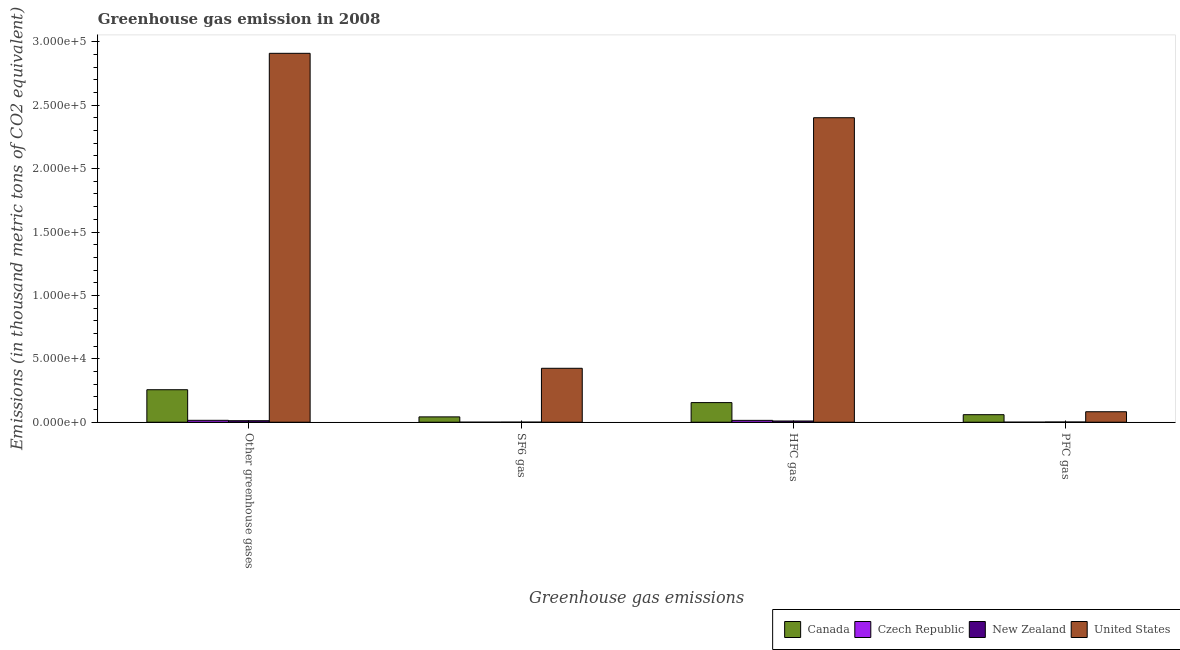How many different coloured bars are there?
Ensure brevity in your answer.  4. Are the number of bars per tick equal to the number of legend labels?
Offer a terse response. Yes. How many bars are there on the 3rd tick from the left?
Make the answer very short. 4. How many bars are there on the 2nd tick from the right?
Offer a very short reply. 4. What is the label of the 2nd group of bars from the left?
Your response must be concise. SF6 gas. Across all countries, what is the maximum emission of pfc gas?
Provide a succinct answer. 8264. Across all countries, what is the minimum emission of greenhouse gases?
Offer a very short reply. 1199.3. In which country was the emission of hfc gas maximum?
Give a very brief answer. United States. In which country was the emission of sf6 gas minimum?
Provide a short and direct response. Czech Republic. What is the total emission of pfc gas in the graph?
Make the answer very short. 1.44e+04. What is the difference between the emission of sf6 gas in Canada and that in New Zealand?
Offer a terse response. 4147.3. What is the difference between the emission of greenhouse gases in Czech Republic and the emission of pfc gas in United States?
Offer a terse response. -6767. What is the average emission of sf6 gas per country?
Offer a terse response. 1.17e+04. What is the difference between the emission of pfc gas and emission of greenhouse gases in Canada?
Keep it short and to the point. -1.97e+04. What is the ratio of the emission of pfc gas in Canada to that in New Zealand?
Give a very brief answer. 35.72. What is the difference between the highest and the second highest emission of sf6 gas?
Your answer should be very brief. 3.83e+04. What is the difference between the highest and the lowest emission of greenhouse gases?
Provide a short and direct response. 2.90e+05. Is the sum of the emission of pfc gas in United States and Czech Republic greater than the maximum emission of hfc gas across all countries?
Give a very brief answer. No. What does the 2nd bar from the left in PFC gas represents?
Offer a very short reply. Czech Republic. Is it the case that in every country, the sum of the emission of greenhouse gases and emission of sf6 gas is greater than the emission of hfc gas?
Ensure brevity in your answer.  Yes. How many bars are there?
Your answer should be very brief. 16. Are all the bars in the graph horizontal?
Give a very brief answer. No. How many countries are there in the graph?
Give a very brief answer. 4. What is the difference between two consecutive major ticks on the Y-axis?
Ensure brevity in your answer.  5.00e+04. Are the values on the major ticks of Y-axis written in scientific E-notation?
Offer a very short reply. Yes. Does the graph contain any zero values?
Offer a very short reply. No. How many legend labels are there?
Keep it short and to the point. 4. How are the legend labels stacked?
Your answer should be compact. Horizontal. What is the title of the graph?
Offer a terse response. Greenhouse gas emission in 2008. What is the label or title of the X-axis?
Provide a short and direct response. Greenhouse gas emissions. What is the label or title of the Y-axis?
Provide a succinct answer. Emissions (in thousand metric tons of CO2 equivalent). What is the Emissions (in thousand metric tons of CO2 equivalent) in Canada in Other greenhouse gases?
Your answer should be very brief. 2.56e+04. What is the Emissions (in thousand metric tons of CO2 equivalent) of Czech Republic in Other greenhouse gases?
Your answer should be compact. 1497. What is the Emissions (in thousand metric tons of CO2 equivalent) of New Zealand in Other greenhouse gases?
Your answer should be very brief. 1199.3. What is the Emissions (in thousand metric tons of CO2 equivalent) of United States in Other greenhouse gases?
Keep it short and to the point. 2.91e+05. What is the Emissions (in thousand metric tons of CO2 equivalent) of Canada in SF6 gas?
Give a very brief answer. 4208.8. What is the Emissions (in thousand metric tons of CO2 equivalent) of Czech Republic in SF6 gas?
Your answer should be very brief. 4.7. What is the Emissions (in thousand metric tons of CO2 equivalent) of New Zealand in SF6 gas?
Offer a very short reply. 61.5. What is the Emissions (in thousand metric tons of CO2 equivalent) in United States in SF6 gas?
Provide a succinct answer. 4.25e+04. What is the Emissions (in thousand metric tons of CO2 equivalent) in Canada in HFC gas?
Offer a very short reply. 1.55e+04. What is the Emissions (in thousand metric tons of CO2 equivalent) in Czech Republic in HFC gas?
Keep it short and to the point. 1459. What is the Emissions (in thousand metric tons of CO2 equivalent) of New Zealand in HFC gas?
Give a very brief answer. 971.4. What is the Emissions (in thousand metric tons of CO2 equivalent) in United States in HFC gas?
Your answer should be very brief. 2.40e+05. What is the Emissions (in thousand metric tons of CO2 equivalent) of Canada in PFC gas?
Your answer should be very brief. 5943.7. What is the Emissions (in thousand metric tons of CO2 equivalent) of Czech Republic in PFC gas?
Your answer should be compact. 33.3. What is the Emissions (in thousand metric tons of CO2 equivalent) of New Zealand in PFC gas?
Provide a short and direct response. 166.4. What is the Emissions (in thousand metric tons of CO2 equivalent) in United States in PFC gas?
Keep it short and to the point. 8264. Across all Greenhouse gas emissions, what is the maximum Emissions (in thousand metric tons of CO2 equivalent) in Canada?
Your response must be concise. 2.56e+04. Across all Greenhouse gas emissions, what is the maximum Emissions (in thousand metric tons of CO2 equivalent) of Czech Republic?
Offer a terse response. 1497. Across all Greenhouse gas emissions, what is the maximum Emissions (in thousand metric tons of CO2 equivalent) of New Zealand?
Keep it short and to the point. 1199.3. Across all Greenhouse gas emissions, what is the maximum Emissions (in thousand metric tons of CO2 equivalent) of United States?
Your answer should be very brief. 2.91e+05. Across all Greenhouse gas emissions, what is the minimum Emissions (in thousand metric tons of CO2 equivalent) in Canada?
Your answer should be compact. 4208.8. Across all Greenhouse gas emissions, what is the minimum Emissions (in thousand metric tons of CO2 equivalent) of New Zealand?
Keep it short and to the point. 61.5. Across all Greenhouse gas emissions, what is the minimum Emissions (in thousand metric tons of CO2 equivalent) in United States?
Ensure brevity in your answer.  8264. What is the total Emissions (in thousand metric tons of CO2 equivalent) of Canada in the graph?
Keep it short and to the point. 5.13e+04. What is the total Emissions (in thousand metric tons of CO2 equivalent) of Czech Republic in the graph?
Provide a succinct answer. 2994. What is the total Emissions (in thousand metric tons of CO2 equivalent) of New Zealand in the graph?
Offer a terse response. 2398.6. What is the total Emissions (in thousand metric tons of CO2 equivalent) in United States in the graph?
Offer a terse response. 5.82e+05. What is the difference between the Emissions (in thousand metric tons of CO2 equivalent) of Canada in Other greenhouse gases and that in SF6 gas?
Offer a terse response. 2.14e+04. What is the difference between the Emissions (in thousand metric tons of CO2 equivalent) of Czech Republic in Other greenhouse gases and that in SF6 gas?
Ensure brevity in your answer.  1492.3. What is the difference between the Emissions (in thousand metric tons of CO2 equivalent) in New Zealand in Other greenhouse gases and that in SF6 gas?
Ensure brevity in your answer.  1137.8. What is the difference between the Emissions (in thousand metric tons of CO2 equivalent) in United States in Other greenhouse gases and that in SF6 gas?
Provide a succinct answer. 2.48e+05. What is the difference between the Emissions (in thousand metric tons of CO2 equivalent) of Canada in Other greenhouse gases and that in HFC gas?
Your response must be concise. 1.02e+04. What is the difference between the Emissions (in thousand metric tons of CO2 equivalent) of Czech Republic in Other greenhouse gases and that in HFC gas?
Make the answer very short. 38. What is the difference between the Emissions (in thousand metric tons of CO2 equivalent) in New Zealand in Other greenhouse gases and that in HFC gas?
Make the answer very short. 227.9. What is the difference between the Emissions (in thousand metric tons of CO2 equivalent) in United States in Other greenhouse gases and that in HFC gas?
Your answer should be compact. 5.08e+04. What is the difference between the Emissions (in thousand metric tons of CO2 equivalent) in Canada in Other greenhouse gases and that in PFC gas?
Provide a short and direct response. 1.97e+04. What is the difference between the Emissions (in thousand metric tons of CO2 equivalent) in Czech Republic in Other greenhouse gases and that in PFC gas?
Make the answer very short. 1463.7. What is the difference between the Emissions (in thousand metric tons of CO2 equivalent) in New Zealand in Other greenhouse gases and that in PFC gas?
Make the answer very short. 1032.9. What is the difference between the Emissions (in thousand metric tons of CO2 equivalent) of United States in Other greenhouse gases and that in PFC gas?
Your response must be concise. 2.83e+05. What is the difference between the Emissions (in thousand metric tons of CO2 equivalent) of Canada in SF6 gas and that in HFC gas?
Offer a terse response. -1.13e+04. What is the difference between the Emissions (in thousand metric tons of CO2 equivalent) in Czech Republic in SF6 gas and that in HFC gas?
Your answer should be compact. -1454.3. What is the difference between the Emissions (in thousand metric tons of CO2 equivalent) in New Zealand in SF6 gas and that in HFC gas?
Offer a terse response. -909.9. What is the difference between the Emissions (in thousand metric tons of CO2 equivalent) of United States in SF6 gas and that in HFC gas?
Provide a succinct answer. -1.98e+05. What is the difference between the Emissions (in thousand metric tons of CO2 equivalent) of Canada in SF6 gas and that in PFC gas?
Keep it short and to the point. -1734.9. What is the difference between the Emissions (in thousand metric tons of CO2 equivalent) in Czech Republic in SF6 gas and that in PFC gas?
Provide a short and direct response. -28.6. What is the difference between the Emissions (in thousand metric tons of CO2 equivalent) in New Zealand in SF6 gas and that in PFC gas?
Offer a terse response. -104.9. What is the difference between the Emissions (in thousand metric tons of CO2 equivalent) in United States in SF6 gas and that in PFC gas?
Offer a very short reply. 3.43e+04. What is the difference between the Emissions (in thousand metric tons of CO2 equivalent) in Canada in HFC gas and that in PFC gas?
Make the answer very short. 9531.1. What is the difference between the Emissions (in thousand metric tons of CO2 equivalent) in Czech Republic in HFC gas and that in PFC gas?
Make the answer very short. 1425.7. What is the difference between the Emissions (in thousand metric tons of CO2 equivalent) in New Zealand in HFC gas and that in PFC gas?
Offer a very short reply. 805. What is the difference between the Emissions (in thousand metric tons of CO2 equivalent) in United States in HFC gas and that in PFC gas?
Ensure brevity in your answer.  2.32e+05. What is the difference between the Emissions (in thousand metric tons of CO2 equivalent) of Canada in Other greenhouse gases and the Emissions (in thousand metric tons of CO2 equivalent) of Czech Republic in SF6 gas?
Provide a short and direct response. 2.56e+04. What is the difference between the Emissions (in thousand metric tons of CO2 equivalent) in Canada in Other greenhouse gases and the Emissions (in thousand metric tons of CO2 equivalent) in New Zealand in SF6 gas?
Provide a succinct answer. 2.56e+04. What is the difference between the Emissions (in thousand metric tons of CO2 equivalent) in Canada in Other greenhouse gases and the Emissions (in thousand metric tons of CO2 equivalent) in United States in SF6 gas?
Provide a short and direct response. -1.69e+04. What is the difference between the Emissions (in thousand metric tons of CO2 equivalent) of Czech Republic in Other greenhouse gases and the Emissions (in thousand metric tons of CO2 equivalent) of New Zealand in SF6 gas?
Provide a short and direct response. 1435.5. What is the difference between the Emissions (in thousand metric tons of CO2 equivalent) of Czech Republic in Other greenhouse gases and the Emissions (in thousand metric tons of CO2 equivalent) of United States in SF6 gas?
Give a very brief answer. -4.10e+04. What is the difference between the Emissions (in thousand metric tons of CO2 equivalent) in New Zealand in Other greenhouse gases and the Emissions (in thousand metric tons of CO2 equivalent) in United States in SF6 gas?
Keep it short and to the point. -4.13e+04. What is the difference between the Emissions (in thousand metric tons of CO2 equivalent) in Canada in Other greenhouse gases and the Emissions (in thousand metric tons of CO2 equivalent) in Czech Republic in HFC gas?
Your response must be concise. 2.42e+04. What is the difference between the Emissions (in thousand metric tons of CO2 equivalent) of Canada in Other greenhouse gases and the Emissions (in thousand metric tons of CO2 equivalent) of New Zealand in HFC gas?
Your response must be concise. 2.47e+04. What is the difference between the Emissions (in thousand metric tons of CO2 equivalent) of Canada in Other greenhouse gases and the Emissions (in thousand metric tons of CO2 equivalent) of United States in HFC gas?
Offer a terse response. -2.14e+05. What is the difference between the Emissions (in thousand metric tons of CO2 equivalent) in Czech Republic in Other greenhouse gases and the Emissions (in thousand metric tons of CO2 equivalent) in New Zealand in HFC gas?
Make the answer very short. 525.6. What is the difference between the Emissions (in thousand metric tons of CO2 equivalent) of Czech Republic in Other greenhouse gases and the Emissions (in thousand metric tons of CO2 equivalent) of United States in HFC gas?
Provide a succinct answer. -2.39e+05. What is the difference between the Emissions (in thousand metric tons of CO2 equivalent) in New Zealand in Other greenhouse gases and the Emissions (in thousand metric tons of CO2 equivalent) in United States in HFC gas?
Offer a very short reply. -2.39e+05. What is the difference between the Emissions (in thousand metric tons of CO2 equivalent) of Canada in Other greenhouse gases and the Emissions (in thousand metric tons of CO2 equivalent) of Czech Republic in PFC gas?
Your response must be concise. 2.56e+04. What is the difference between the Emissions (in thousand metric tons of CO2 equivalent) in Canada in Other greenhouse gases and the Emissions (in thousand metric tons of CO2 equivalent) in New Zealand in PFC gas?
Keep it short and to the point. 2.55e+04. What is the difference between the Emissions (in thousand metric tons of CO2 equivalent) in Canada in Other greenhouse gases and the Emissions (in thousand metric tons of CO2 equivalent) in United States in PFC gas?
Offer a terse response. 1.74e+04. What is the difference between the Emissions (in thousand metric tons of CO2 equivalent) in Czech Republic in Other greenhouse gases and the Emissions (in thousand metric tons of CO2 equivalent) in New Zealand in PFC gas?
Your answer should be compact. 1330.6. What is the difference between the Emissions (in thousand metric tons of CO2 equivalent) in Czech Republic in Other greenhouse gases and the Emissions (in thousand metric tons of CO2 equivalent) in United States in PFC gas?
Your answer should be very brief. -6767. What is the difference between the Emissions (in thousand metric tons of CO2 equivalent) of New Zealand in Other greenhouse gases and the Emissions (in thousand metric tons of CO2 equivalent) of United States in PFC gas?
Your response must be concise. -7064.7. What is the difference between the Emissions (in thousand metric tons of CO2 equivalent) in Canada in SF6 gas and the Emissions (in thousand metric tons of CO2 equivalent) in Czech Republic in HFC gas?
Offer a terse response. 2749.8. What is the difference between the Emissions (in thousand metric tons of CO2 equivalent) of Canada in SF6 gas and the Emissions (in thousand metric tons of CO2 equivalent) of New Zealand in HFC gas?
Your answer should be compact. 3237.4. What is the difference between the Emissions (in thousand metric tons of CO2 equivalent) of Canada in SF6 gas and the Emissions (in thousand metric tons of CO2 equivalent) of United States in HFC gas?
Your answer should be very brief. -2.36e+05. What is the difference between the Emissions (in thousand metric tons of CO2 equivalent) of Czech Republic in SF6 gas and the Emissions (in thousand metric tons of CO2 equivalent) of New Zealand in HFC gas?
Offer a terse response. -966.7. What is the difference between the Emissions (in thousand metric tons of CO2 equivalent) of Czech Republic in SF6 gas and the Emissions (in thousand metric tons of CO2 equivalent) of United States in HFC gas?
Your response must be concise. -2.40e+05. What is the difference between the Emissions (in thousand metric tons of CO2 equivalent) of New Zealand in SF6 gas and the Emissions (in thousand metric tons of CO2 equivalent) of United States in HFC gas?
Provide a succinct answer. -2.40e+05. What is the difference between the Emissions (in thousand metric tons of CO2 equivalent) of Canada in SF6 gas and the Emissions (in thousand metric tons of CO2 equivalent) of Czech Republic in PFC gas?
Your answer should be compact. 4175.5. What is the difference between the Emissions (in thousand metric tons of CO2 equivalent) of Canada in SF6 gas and the Emissions (in thousand metric tons of CO2 equivalent) of New Zealand in PFC gas?
Your answer should be compact. 4042.4. What is the difference between the Emissions (in thousand metric tons of CO2 equivalent) of Canada in SF6 gas and the Emissions (in thousand metric tons of CO2 equivalent) of United States in PFC gas?
Provide a succinct answer. -4055.2. What is the difference between the Emissions (in thousand metric tons of CO2 equivalent) of Czech Republic in SF6 gas and the Emissions (in thousand metric tons of CO2 equivalent) of New Zealand in PFC gas?
Your answer should be compact. -161.7. What is the difference between the Emissions (in thousand metric tons of CO2 equivalent) in Czech Republic in SF6 gas and the Emissions (in thousand metric tons of CO2 equivalent) in United States in PFC gas?
Give a very brief answer. -8259.3. What is the difference between the Emissions (in thousand metric tons of CO2 equivalent) in New Zealand in SF6 gas and the Emissions (in thousand metric tons of CO2 equivalent) in United States in PFC gas?
Give a very brief answer. -8202.5. What is the difference between the Emissions (in thousand metric tons of CO2 equivalent) of Canada in HFC gas and the Emissions (in thousand metric tons of CO2 equivalent) of Czech Republic in PFC gas?
Your answer should be compact. 1.54e+04. What is the difference between the Emissions (in thousand metric tons of CO2 equivalent) in Canada in HFC gas and the Emissions (in thousand metric tons of CO2 equivalent) in New Zealand in PFC gas?
Offer a terse response. 1.53e+04. What is the difference between the Emissions (in thousand metric tons of CO2 equivalent) in Canada in HFC gas and the Emissions (in thousand metric tons of CO2 equivalent) in United States in PFC gas?
Make the answer very short. 7210.8. What is the difference between the Emissions (in thousand metric tons of CO2 equivalent) of Czech Republic in HFC gas and the Emissions (in thousand metric tons of CO2 equivalent) of New Zealand in PFC gas?
Your response must be concise. 1292.6. What is the difference between the Emissions (in thousand metric tons of CO2 equivalent) of Czech Republic in HFC gas and the Emissions (in thousand metric tons of CO2 equivalent) of United States in PFC gas?
Give a very brief answer. -6805. What is the difference between the Emissions (in thousand metric tons of CO2 equivalent) of New Zealand in HFC gas and the Emissions (in thousand metric tons of CO2 equivalent) of United States in PFC gas?
Your response must be concise. -7292.6. What is the average Emissions (in thousand metric tons of CO2 equivalent) of Canada per Greenhouse gas emissions?
Provide a short and direct response. 1.28e+04. What is the average Emissions (in thousand metric tons of CO2 equivalent) of Czech Republic per Greenhouse gas emissions?
Provide a succinct answer. 748.5. What is the average Emissions (in thousand metric tons of CO2 equivalent) of New Zealand per Greenhouse gas emissions?
Provide a short and direct response. 599.65. What is the average Emissions (in thousand metric tons of CO2 equivalent) of United States per Greenhouse gas emissions?
Ensure brevity in your answer.  1.45e+05. What is the difference between the Emissions (in thousand metric tons of CO2 equivalent) of Canada and Emissions (in thousand metric tons of CO2 equivalent) of Czech Republic in Other greenhouse gases?
Provide a succinct answer. 2.41e+04. What is the difference between the Emissions (in thousand metric tons of CO2 equivalent) in Canada and Emissions (in thousand metric tons of CO2 equivalent) in New Zealand in Other greenhouse gases?
Provide a succinct answer. 2.44e+04. What is the difference between the Emissions (in thousand metric tons of CO2 equivalent) of Canada and Emissions (in thousand metric tons of CO2 equivalent) of United States in Other greenhouse gases?
Your answer should be compact. -2.65e+05. What is the difference between the Emissions (in thousand metric tons of CO2 equivalent) of Czech Republic and Emissions (in thousand metric tons of CO2 equivalent) of New Zealand in Other greenhouse gases?
Your response must be concise. 297.7. What is the difference between the Emissions (in thousand metric tons of CO2 equivalent) of Czech Republic and Emissions (in thousand metric tons of CO2 equivalent) of United States in Other greenhouse gases?
Give a very brief answer. -2.89e+05. What is the difference between the Emissions (in thousand metric tons of CO2 equivalent) in New Zealand and Emissions (in thousand metric tons of CO2 equivalent) in United States in Other greenhouse gases?
Provide a short and direct response. -2.90e+05. What is the difference between the Emissions (in thousand metric tons of CO2 equivalent) in Canada and Emissions (in thousand metric tons of CO2 equivalent) in Czech Republic in SF6 gas?
Provide a short and direct response. 4204.1. What is the difference between the Emissions (in thousand metric tons of CO2 equivalent) in Canada and Emissions (in thousand metric tons of CO2 equivalent) in New Zealand in SF6 gas?
Offer a terse response. 4147.3. What is the difference between the Emissions (in thousand metric tons of CO2 equivalent) in Canada and Emissions (in thousand metric tons of CO2 equivalent) in United States in SF6 gas?
Give a very brief answer. -3.83e+04. What is the difference between the Emissions (in thousand metric tons of CO2 equivalent) in Czech Republic and Emissions (in thousand metric tons of CO2 equivalent) in New Zealand in SF6 gas?
Provide a succinct answer. -56.8. What is the difference between the Emissions (in thousand metric tons of CO2 equivalent) of Czech Republic and Emissions (in thousand metric tons of CO2 equivalent) of United States in SF6 gas?
Ensure brevity in your answer.  -4.25e+04. What is the difference between the Emissions (in thousand metric tons of CO2 equivalent) in New Zealand and Emissions (in thousand metric tons of CO2 equivalent) in United States in SF6 gas?
Make the answer very short. -4.25e+04. What is the difference between the Emissions (in thousand metric tons of CO2 equivalent) in Canada and Emissions (in thousand metric tons of CO2 equivalent) in Czech Republic in HFC gas?
Your response must be concise. 1.40e+04. What is the difference between the Emissions (in thousand metric tons of CO2 equivalent) of Canada and Emissions (in thousand metric tons of CO2 equivalent) of New Zealand in HFC gas?
Offer a very short reply. 1.45e+04. What is the difference between the Emissions (in thousand metric tons of CO2 equivalent) of Canada and Emissions (in thousand metric tons of CO2 equivalent) of United States in HFC gas?
Your answer should be very brief. -2.25e+05. What is the difference between the Emissions (in thousand metric tons of CO2 equivalent) in Czech Republic and Emissions (in thousand metric tons of CO2 equivalent) in New Zealand in HFC gas?
Your answer should be very brief. 487.6. What is the difference between the Emissions (in thousand metric tons of CO2 equivalent) in Czech Republic and Emissions (in thousand metric tons of CO2 equivalent) in United States in HFC gas?
Ensure brevity in your answer.  -2.39e+05. What is the difference between the Emissions (in thousand metric tons of CO2 equivalent) of New Zealand and Emissions (in thousand metric tons of CO2 equivalent) of United States in HFC gas?
Your answer should be compact. -2.39e+05. What is the difference between the Emissions (in thousand metric tons of CO2 equivalent) in Canada and Emissions (in thousand metric tons of CO2 equivalent) in Czech Republic in PFC gas?
Your response must be concise. 5910.4. What is the difference between the Emissions (in thousand metric tons of CO2 equivalent) of Canada and Emissions (in thousand metric tons of CO2 equivalent) of New Zealand in PFC gas?
Give a very brief answer. 5777.3. What is the difference between the Emissions (in thousand metric tons of CO2 equivalent) of Canada and Emissions (in thousand metric tons of CO2 equivalent) of United States in PFC gas?
Provide a short and direct response. -2320.3. What is the difference between the Emissions (in thousand metric tons of CO2 equivalent) of Czech Republic and Emissions (in thousand metric tons of CO2 equivalent) of New Zealand in PFC gas?
Ensure brevity in your answer.  -133.1. What is the difference between the Emissions (in thousand metric tons of CO2 equivalent) in Czech Republic and Emissions (in thousand metric tons of CO2 equivalent) in United States in PFC gas?
Your response must be concise. -8230.7. What is the difference between the Emissions (in thousand metric tons of CO2 equivalent) in New Zealand and Emissions (in thousand metric tons of CO2 equivalent) in United States in PFC gas?
Provide a succinct answer. -8097.6. What is the ratio of the Emissions (in thousand metric tons of CO2 equivalent) of Canada in Other greenhouse gases to that in SF6 gas?
Provide a short and direct response. 6.09. What is the ratio of the Emissions (in thousand metric tons of CO2 equivalent) in Czech Republic in Other greenhouse gases to that in SF6 gas?
Provide a short and direct response. 318.51. What is the ratio of the Emissions (in thousand metric tons of CO2 equivalent) of New Zealand in Other greenhouse gases to that in SF6 gas?
Your answer should be compact. 19.5. What is the ratio of the Emissions (in thousand metric tons of CO2 equivalent) in United States in Other greenhouse gases to that in SF6 gas?
Offer a very short reply. 6.84. What is the ratio of the Emissions (in thousand metric tons of CO2 equivalent) of Canada in Other greenhouse gases to that in HFC gas?
Provide a short and direct response. 1.66. What is the ratio of the Emissions (in thousand metric tons of CO2 equivalent) in New Zealand in Other greenhouse gases to that in HFC gas?
Your answer should be compact. 1.23. What is the ratio of the Emissions (in thousand metric tons of CO2 equivalent) of United States in Other greenhouse gases to that in HFC gas?
Keep it short and to the point. 1.21. What is the ratio of the Emissions (in thousand metric tons of CO2 equivalent) of Canada in Other greenhouse gases to that in PFC gas?
Your response must be concise. 4.31. What is the ratio of the Emissions (in thousand metric tons of CO2 equivalent) of Czech Republic in Other greenhouse gases to that in PFC gas?
Give a very brief answer. 44.95. What is the ratio of the Emissions (in thousand metric tons of CO2 equivalent) of New Zealand in Other greenhouse gases to that in PFC gas?
Offer a terse response. 7.21. What is the ratio of the Emissions (in thousand metric tons of CO2 equivalent) in United States in Other greenhouse gases to that in PFC gas?
Offer a very short reply. 35.2. What is the ratio of the Emissions (in thousand metric tons of CO2 equivalent) in Canada in SF6 gas to that in HFC gas?
Provide a short and direct response. 0.27. What is the ratio of the Emissions (in thousand metric tons of CO2 equivalent) in Czech Republic in SF6 gas to that in HFC gas?
Ensure brevity in your answer.  0. What is the ratio of the Emissions (in thousand metric tons of CO2 equivalent) in New Zealand in SF6 gas to that in HFC gas?
Offer a very short reply. 0.06. What is the ratio of the Emissions (in thousand metric tons of CO2 equivalent) of United States in SF6 gas to that in HFC gas?
Provide a succinct answer. 0.18. What is the ratio of the Emissions (in thousand metric tons of CO2 equivalent) in Canada in SF6 gas to that in PFC gas?
Your answer should be compact. 0.71. What is the ratio of the Emissions (in thousand metric tons of CO2 equivalent) of Czech Republic in SF6 gas to that in PFC gas?
Give a very brief answer. 0.14. What is the ratio of the Emissions (in thousand metric tons of CO2 equivalent) in New Zealand in SF6 gas to that in PFC gas?
Your response must be concise. 0.37. What is the ratio of the Emissions (in thousand metric tons of CO2 equivalent) in United States in SF6 gas to that in PFC gas?
Keep it short and to the point. 5.15. What is the ratio of the Emissions (in thousand metric tons of CO2 equivalent) of Canada in HFC gas to that in PFC gas?
Give a very brief answer. 2.6. What is the ratio of the Emissions (in thousand metric tons of CO2 equivalent) of Czech Republic in HFC gas to that in PFC gas?
Your response must be concise. 43.81. What is the ratio of the Emissions (in thousand metric tons of CO2 equivalent) in New Zealand in HFC gas to that in PFC gas?
Make the answer very short. 5.84. What is the ratio of the Emissions (in thousand metric tons of CO2 equivalent) in United States in HFC gas to that in PFC gas?
Offer a terse response. 29.06. What is the difference between the highest and the second highest Emissions (in thousand metric tons of CO2 equivalent) of Canada?
Make the answer very short. 1.02e+04. What is the difference between the highest and the second highest Emissions (in thousand metric tons of CO2 equivalent) in Czech Republic?
Give a very brief answer. 38. What is the difference between the highest and the second highest Emissions (in thousand metric tons of CO2 equivalent) of New Zealand?
Give a very brief answer. 227.9. What is the difference between the highest and the second highest Emissions (in thousand metric tons of CO2 equivalent) in United States?
Your answer should be very brief. 5.08e+04. What is the difference between the highest and the lowest Emissions (in thousand metric tons of CO2 equivalent) of Canada?
Make the answer very short. 2.14e+04. What is the difference between the highest and the lowest Emissions (in thousand metric tons of CO2 equivalent) of Czech Republic?
Provide a succinct answer. 1492.3. What is the difference between the highest and the lowest Emissions (in thousand metric tons of CO2 equivalent) in New Zealand?
Your answer should be compact. 1137.8. What is the difference between the highest and the lowest Emissions (in thousand metric tons of CO2 equivalent) in United States?
Your response must be concise. 2.83e+05. 